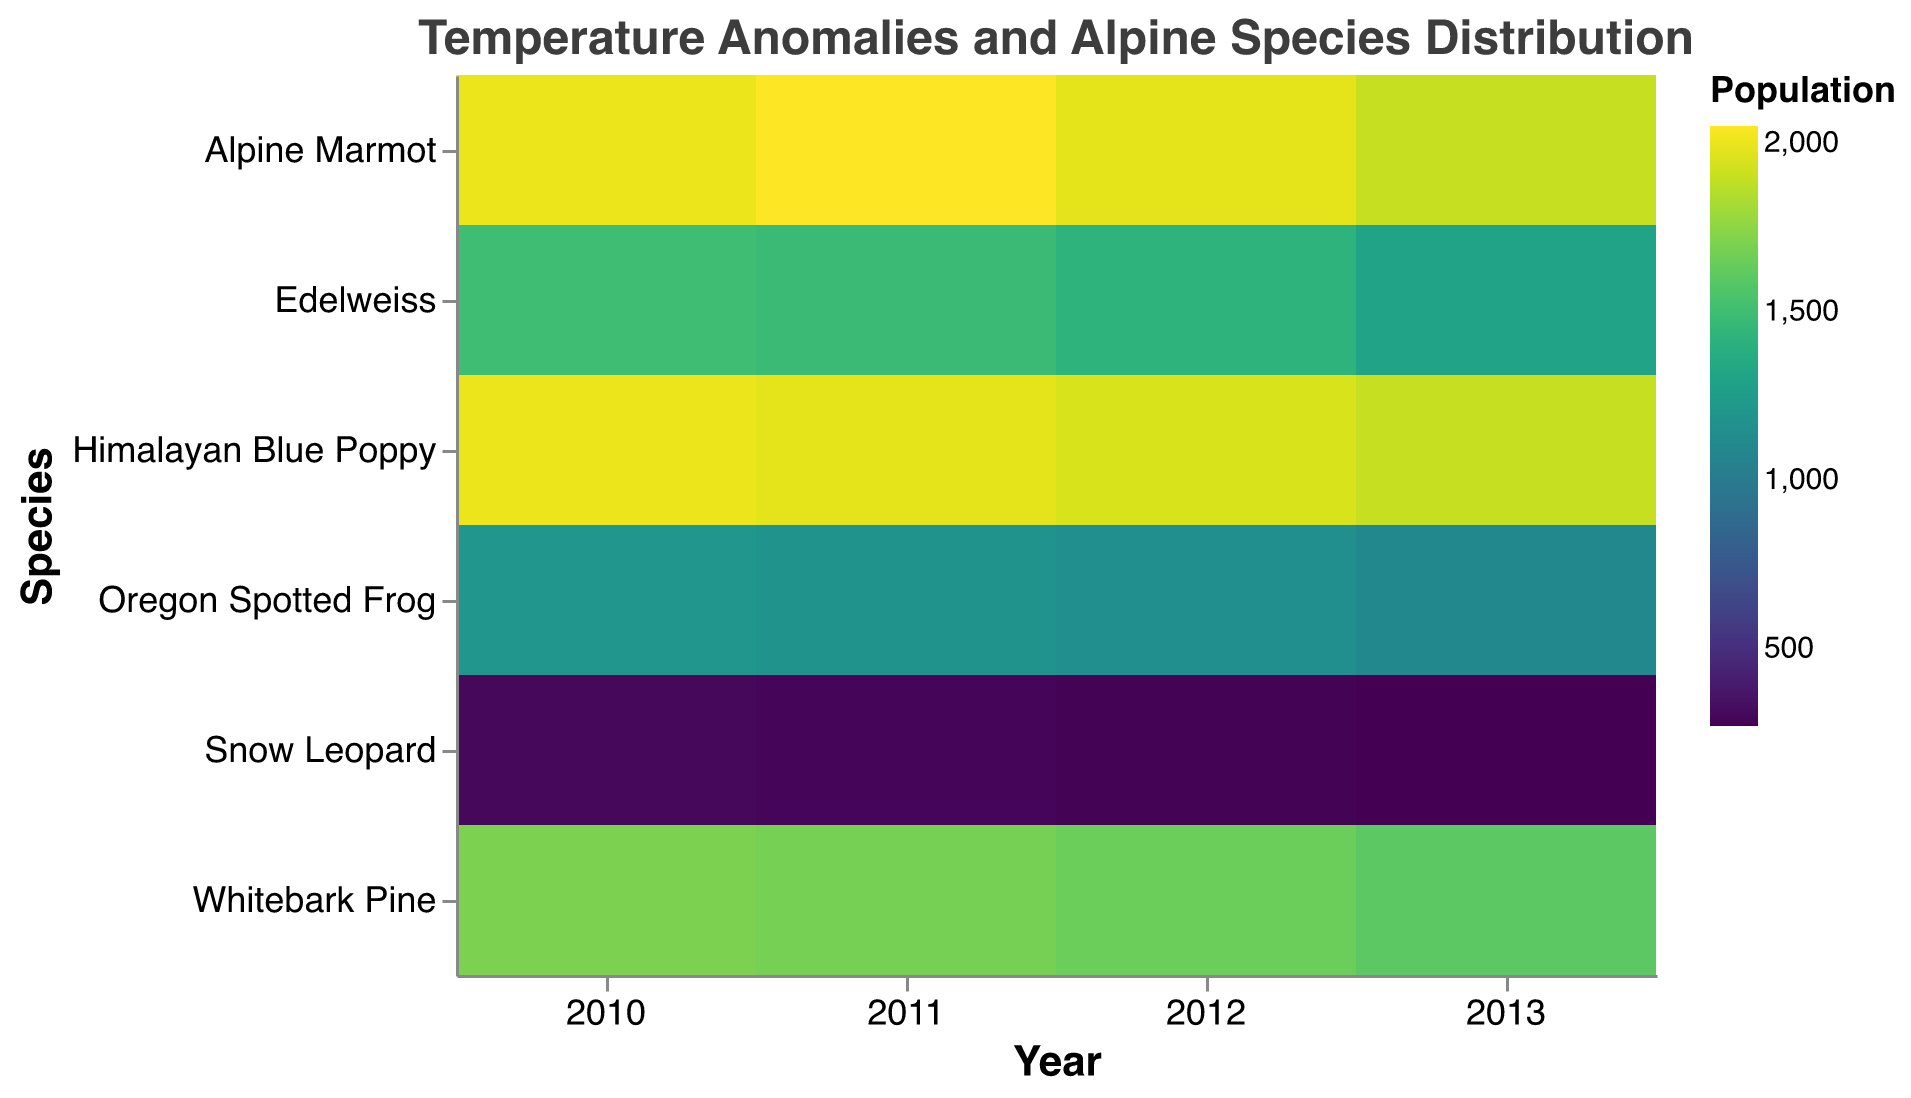How many unique species are shown in the heatmap? Start by looking at the y-axis labeled "Species" to count the unique species names listed.
Answer: 8 Which year has the highest population for Alpine Marmot? Find Alpine Marmot on the y-axis, and then trace horizontally to see which color block signifies the highest population. Hover over the blocks if necessary for exact values.
Answer: 2011 What is the population difference of Edelweiss between 2010 and 2013? Look for Edelweiss on the y-axis and then compare the 2010 population block's tooltip value to the 2013 population block's value. Subtract the smaller from the larger.
Answer: 200 (1500 - 1300) Which species in the Rockies has the smallest population in 2013? Locate the Rockies species on the y-axis, focus on the year 2013, and identify which color block has the lowest value or by using tooltips.
Answer: Oregon Spotted Frog Between 2010 and 2013, how did the population of the Himalayan Blue Poppy change as the temperature anomaly increased? Follow the trend for the Himalayan Blue Poppy on the y-axis, checking each year from 2010 to 2013, and observe the tooltip for population and temperature anomaly changes.
Answer: Decreased by 100 (2000 to 1900) as anomaly increased from 0.8 to 1.6 Which location had the highest temperature anomaly in 2013, and what was its value? For the year 2013, check the tooltip for each location to determine which has the highest temperature anomaly value.
Answer: Rockies, 1.8 Between the Alps and Himalayas, which had a more stable population for plant species from 2010 to 2013? Compare the population values for Edelweiss in the Alps and Himalayan Blue Poppy in the Himalayas over the years. Check the tooltip details for consistency.
Answer: Himalayas (1900 from 2000) For the Alpine Marmot, what year had the biggest decrease in population compared to the previous year? Look at the population values for Alpine Marmot across years. Calculate the differences between successive years and identify the greatest decrease.
Answer: 2013 (decreased by 80 from 1980 to 1900) Which location shows the highest population for its plant species in 2010? Identify the plant species for each location in 2010 and compare their population values in the tooltips.
Answer: Himalayas (2000 for Himalayan Blue Poppy) 